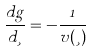<formula> <loc_0><loc_0><loc_500><loc_500>\frac { d g } { d \xi } = - \frac { 1 } { v ( \xi ) } \,</formula> 